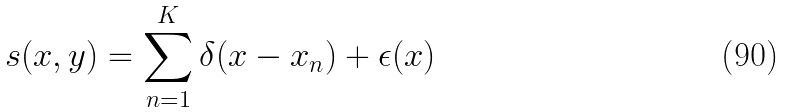<formula> <loc_0><loc_0><loc_500><loc_500>s ( x , y ) = \sum _ { n = 1 } ^ { K } \delta ( x - x _ { n } ) + \epsilon ( x )</formula> 